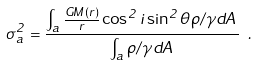Convert formula to latex. <formula><loc_0><loc_0><loc_500><loc_500>\sigma ^ { 2 } _ { a } = \frac { \int _ { a } \frac { G M ( r ) } { r } \cos ^ { 2 } i \sin ^ { 2 } \theta \rho / \gamma d A } { \int _ { a } \rho / \gamma d A } \ .</formula> 